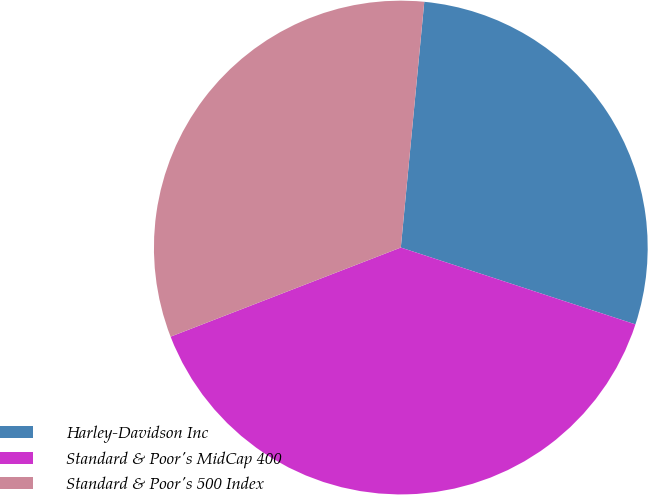<chart> <loc_0><loc_0><loc_500><loc_500><pie_chart><fcel>Harley-Davidson Inc<fcel>Standard & Poor's MidCap 400<fcel>Standard & Poor's 500 Index<nl><fcel>28.52%<fcel>39.08%<fcel>32.39%<nl></chart> 